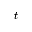<formula> <loc_0><loc_0><loc_500><loc_500>t</formula> 